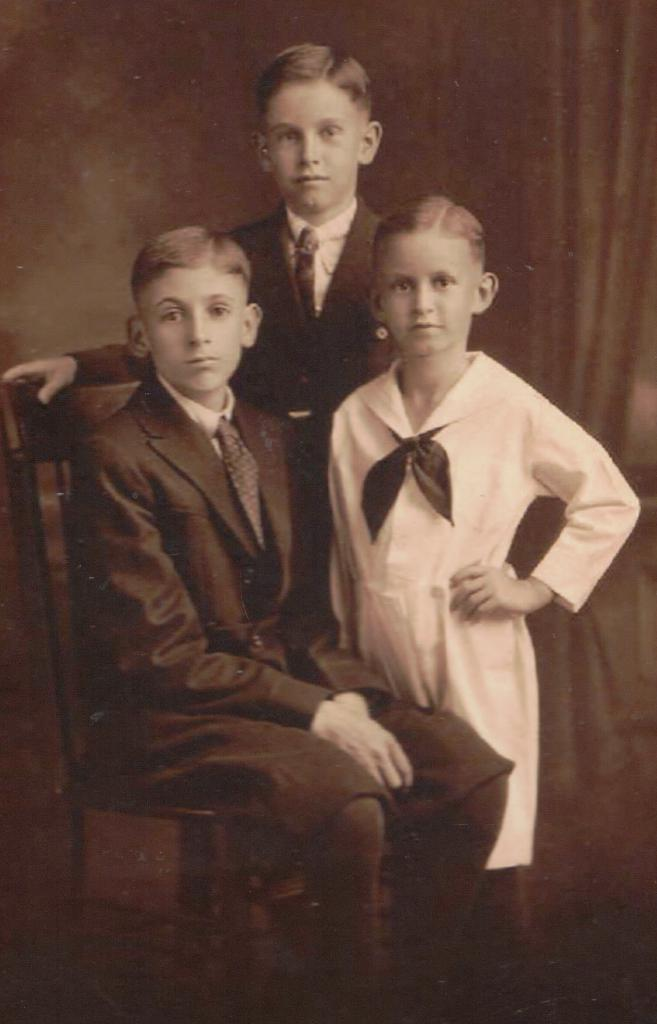How many people are present in the image? There are three people in the image. What is the boy in the image doing? The boy is sitting on a chair. What can be seen in the background of the image? There is a wall in the background of the image. Is there any window treatment present in the image? Yes, there is a curtain associated with the wall in the background. What type of crack can be seen on the wall in the image? There is no crack visible on the wall in the image. 